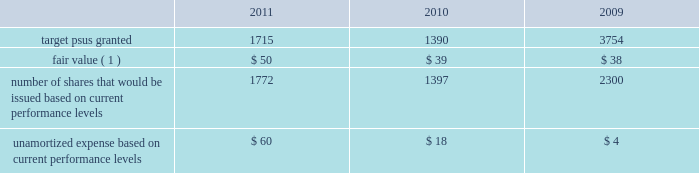Performance share awards the vesting of psas is contingent upon meeting various individual , divisional or company-wide performance conditions , including revenue generation or growth in revenue , pretax income or earnings per share over a one- to five-year period .
The performance conditions are not considered in the determination of the grant date fair value for these awards .
The fair value of psas is based upon the market price of the aon common stock at the date of grant .
Compensation expense is recognized over the performance period , and in certain cases an additional vesting period , based on management 2019s estimate of the number of units expected to vest .
Compensation expense is adjusted to reflect the actual number of shares issued at the end of the programs .
The actual issuance of shares may range from 0-200% ( 0-200 % ) of the target number of psas granted , based on the plan .
Dividend equivalents are not paid on psas .
Information regarding psas granted during the years ended december 31 , 2011 , 2010 and 2009 follows ( shares in thousands , dollars in millions , except fair value ) : .
( 1 ) represents per share weighted average fair value of award at date of grant .
During 2011 , the company issued approximately 1.2 million shares in connection with the 2008 leadership performance plan ( 2018 2018lpp 2019 2019 ) cycle and 0.3 million shares related to a 2006 performance plan .
During 2010 , the company issued approximately 1.6 million shares in connection with the completion of the 2007 lpp cycle and 84000 shares related to other performance plans .
Stock options options to purchase common stock are granted to certain employees at fair value on the date of grant .
Commencing in 2010 , the company ceased granting new stock options with the exception of historical contractual commitments .
Generally , employees are required to complete two continuous years of service before the options begin to vest in increments until the completion of a 4-year period of continuous employment , although a number of options were granted that require five continuous years of service before the options are fully vested .
Options issued under the lpp program vest ratable over 3 years with a six year term .
The maximum contractual term on stock options is generally ten years from the date of grant .
Aon uses a lattice-binomial option-pricing model to value stock options .
Lattice-based option valuation models use a range of assumptions over the expected term of the options .
Expected volatilities are based on the average of the historical volatility of aon 2019s stock price and the implied volatility of traded options and aon 2019s stock .
The valuation model stratifies employees between those receiving lpp options , special stock plan ( 2018 2018ssp 2019 2019 ) options , and all other option grants .
The company believes that this stratification better represents prospective stock option exercise patterns .
The expected dividend yield assumption is based on the company 2019s historical and expected future dividend rate .
The risk-free rate for periods within the contractual life of the option is based on the u.s .
Treasury yield curve in effect at the time of grant .
The expected life of employee stock options represents the weighted-average period stock options are expected to remain outstanding and is a derived output of the lattice-binomial model. .
What was the ratio of the shares in connection with the 2008 leadership performance plan ( 2018 2018lpp 2019 2019 ) cycle to the 2006 performance plan issued in 2011? 
Rationale: in 2011 the company issued 4 shares in connection with the 2008 leadership performance plan ( 2018 2018lpp 2019 2019 ) cycle to the per share of the 2006 performance plan
Computations: (1.2 / 0.3)
Answer: 4.0. 